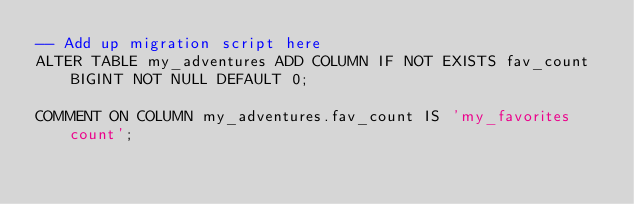Convert code to text. <code><loc_0><loc_0><loc_500><loc_500><_SQL_>-- Add up migration script here
ALTER TABLE my_adventures ADD COLUMN IF NOT EXISTS fav_count BIGINT NOT NULL DEFAULT 0;

COMMENT ON COLUMN my_adventures.fav_count IS 'my_favorites count';</code> 